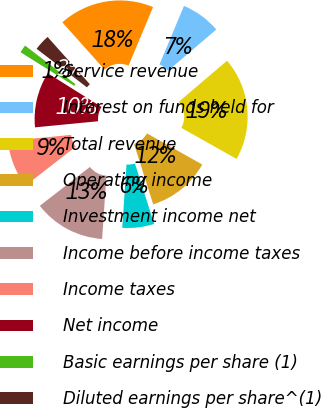<chart> <loc_0><loc_0><loc_500><loc_500><pie_chart><fcel>Service revenue<fcel>Interest on funds held for<fcel>Total revenue<fcel>Operating income<fcel>Investment income net<fcel>Income before income taxes<fcel>Income taxes<fcel>Net income<fcel>Basic earnings per share (1)<fcel>Diluted earnings per share^(1)<nl><fcel>17.91%<fcel>7.46%<fcel>19.4%<fcel>11.94%<fcel>5.97%<fcel>13.43%<fcel>8.96%<fcel>10.45%<fcel>1.49%<fcel>2.99%<nl></chart> 